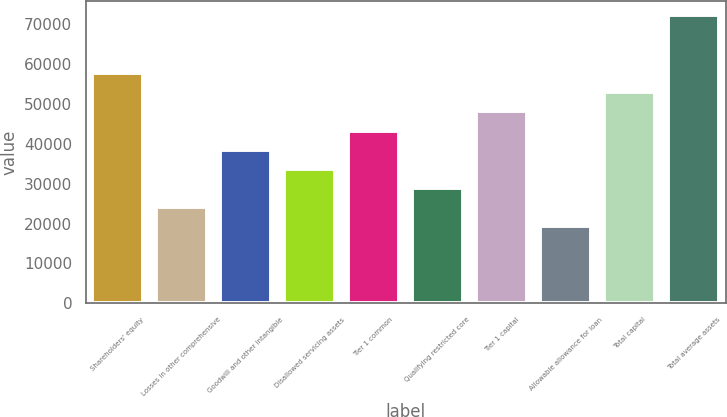<chart> <loc_0><loc_0><loc_500><loc_500><bar_chart><fcel>Shareholders' equity<fcel>Losses in other comprehensive<fcel>Goodwill and other intangible<fcel>Disallowed servicing assets<fcel>Tier 1 common<fcel>Qualifying restricted core<fcel>Tier 1 capital<fcel>Allowable allowance for loan<fcel>Total capital<fcel>Total average assets<nl><fcel>57781.3<fcel>24078.8<fcel>38522.7<fcel>33708.1<fcel>43337.3<fcel>28893.4<fcel>48152<fcel>19264.1<fcel>52966.7<fcel>72225.2<nl></chart> 